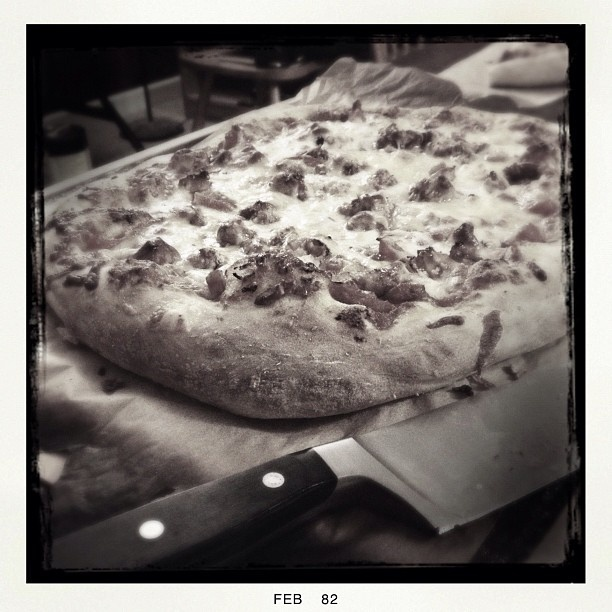Describe the objects in this image and their specific colors. I can see pizza in white, gray, darkgray, and lightgray tones, knife in white, black, gray, and darkgray tones, and chair in white, black, and gray tones in this image. 